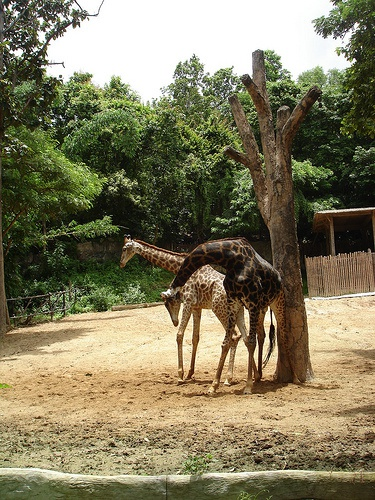Describe the objects in this image and their specific colors. I can see giraffe in gray, black, and maroon tones and giraffe in gray, maroon, and black tones in this image. 